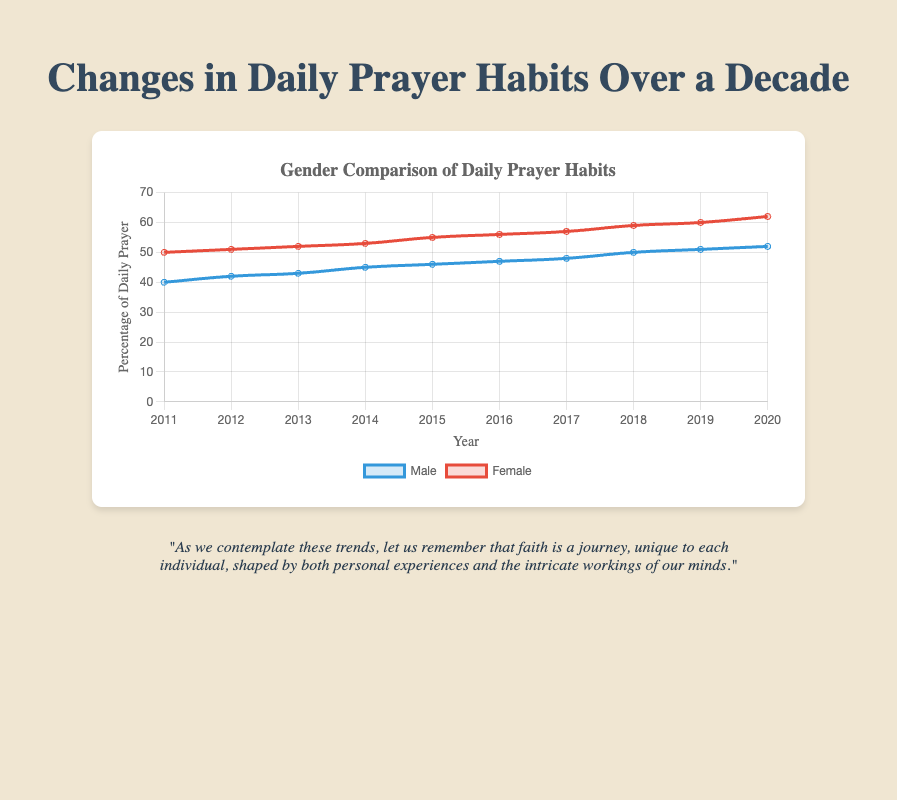Which gender had a higher percentage of daily prayer in 2015? By looking at the line chart, identify the data points for male and female in 2015. From the chart, males had a percentage of 46 and females had 55, so females had a higher percentage.
Answer: Female What is the difference in the percentage of daily prayer between males and females in 2020? Refer to the data points for both genders in the year 2020. The male percentage was 52 while the female percentage was 62. The difference is 62 - 52 = 10 percent.
Answer: 10 percent Which year saw a 3% increase in daily prayer habits for males? Start from 2011, notice the increase in percentages each year: 2011 (40), 2012 (42), 2013 (43), 2014 (45). The difference between 43 (2013) and 45 (2014) is 2%. Continue checking until 2017, where the difference between 48 (2017) and 50 (2018) is 2%. Thus, there is no 3% increase year.
Answer: None In which year are both male and female at their closest percentage of daily prayer? Check each year to find the smallest difference between the male and female data points. For example, in 2016, males had 47% whereas females had 56% the difference is 9%. Continue this process and notice that in 2013, males had 43% and females had 52%, making the difference 9%. The closest difference is in 2011, where males had 40% and females had 50%, making a difference of 10%.
Answer: 2011 What is the average percentage of daily prayer for females from 2011 to 2015? Sum the female percentages for the years 2011 to 2015: 50, 51, 52, 53, and 55. The sum is 50 + 51 + 52 + 53 + 55 = 261. Divide by the number of years (5): 261 / 5 = 52.2 percent.
Answer: 52.2 percent Which gender showed a continuous increase in daily prayer every year? Check the data points for both males and females each year to see if the percentages increased continuously. Males increased from 40 to 42, 42 to 43, and so on without any decline. Females also increased from 50 to 51, 51 to 52, and so on without any decline.
Answer: Both What is the total increase in the percentage of daily prayer for males from 2011 to 2020? Find the male percentage in 2011 (40) and in 2020 (52). The total increase is 52 - 40 = 12 percent.
Answer: 12 percent What is the median percentage of daily prayer for males over the decade? List the male percentages: [40, 42, 43, 45, 46, 47, 48, 50, 51, 52]. As there are 10 data points, the median is the average of the 5th and 6th values in the sorted list: (46 + 47) / 2 = 46.5.
Answer: 46.5 percent Which gender had a larger increase (%) in daily prayer from 2018 to 2020? Compare the percentage increase for both genders. In 2018, males had 50% and increased to 52% in 2020 (increase of 2%). Females had 59% in 2018 and increased to 62% in 2020 (increase of 3%). Thus, females had a larger increase.
Answer: Female 